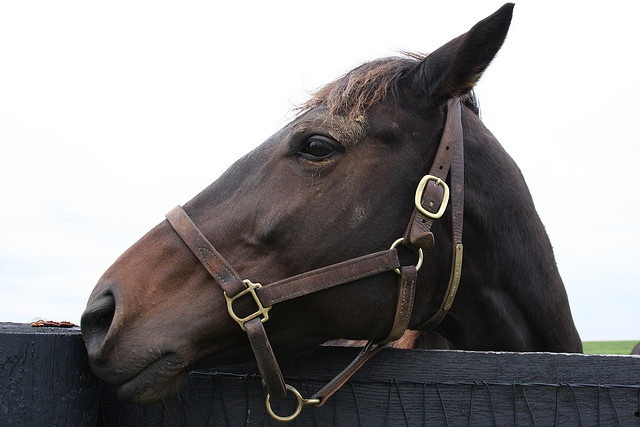Describe the objects in this image and their specific colors. I can see a horse in white, black, and gray tones in this image. 